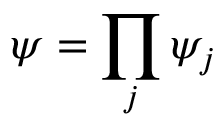Convert formula to latex. <formula><loc_0><loc_0><loc_500><loc_500>\psi = \prod _ { j } \psi _ { j }</formula> 